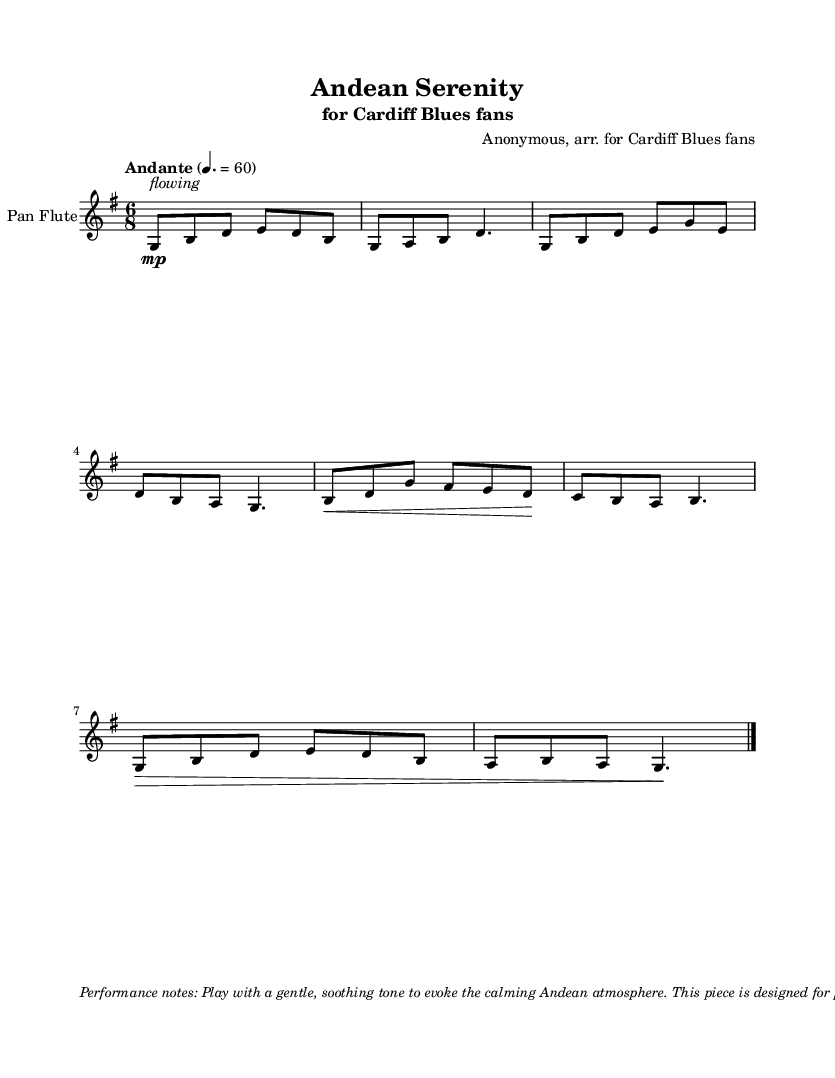What is the tempo marking of this piece? The tempo marking is indicated at the beginning of the score, with the direction "Andante" written above the staff, along with a metronome marking of 60 beats per minute.
Answer: Andante What is the time signature of this music? The time signature is displayed at the beginning of the score, showing 6/8, which indicates six eighth notes per measure.
Answer: 6/8 What is the key signature of this piece? The key signature is shown at the beginning of the score, and it is G major, which has one sharp (F#).
Answer: G major How many measures are in the piece? By counting the distinct sections or phrases in the written music, there are a total of 6 measures included in this excerpt.
Answer: 6 What dynamic marking indicates the player's volume? The dynamic marking is shown at the start of the piece with "mp," which stands for "mezzo-piano," instructing the player to play moderately soft.
Answer: mp Which instrument is this sheet music arranged for? The instrument name appears at the beginning of the score, where it states clearly that the piece is meant for the "Pan Flute."
Answer: Pan Flute What is the performance note suggestion in the music? The performance note is provided in the markup section at the bottom, where it emphasizes playing with a "gentle, soothing tone" to capture the calming Andean atmosphere.
Answer: gentle, soothing tone 